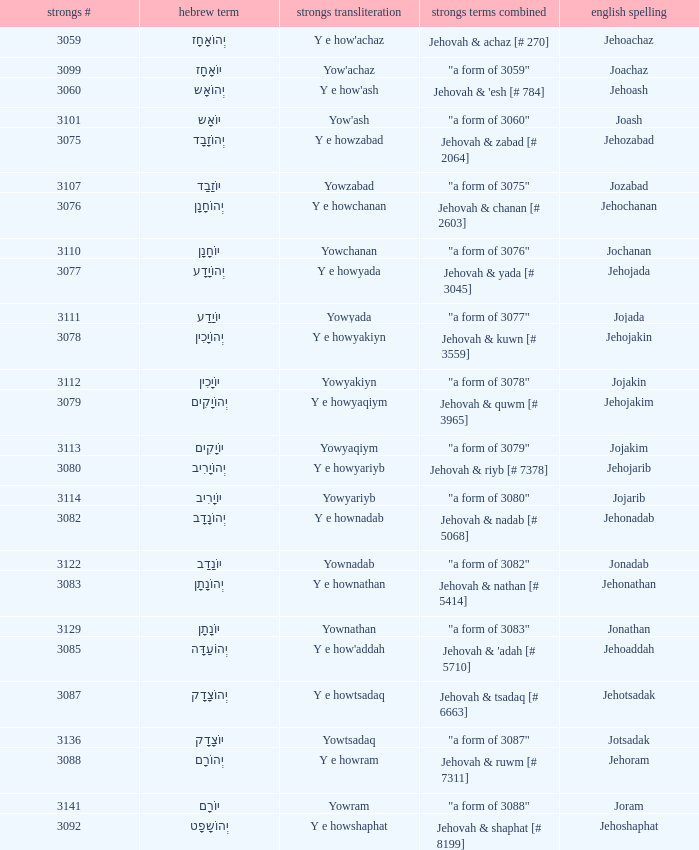What is the strongs words compounded when the english spelling is jonadab? "a form of 3082". 